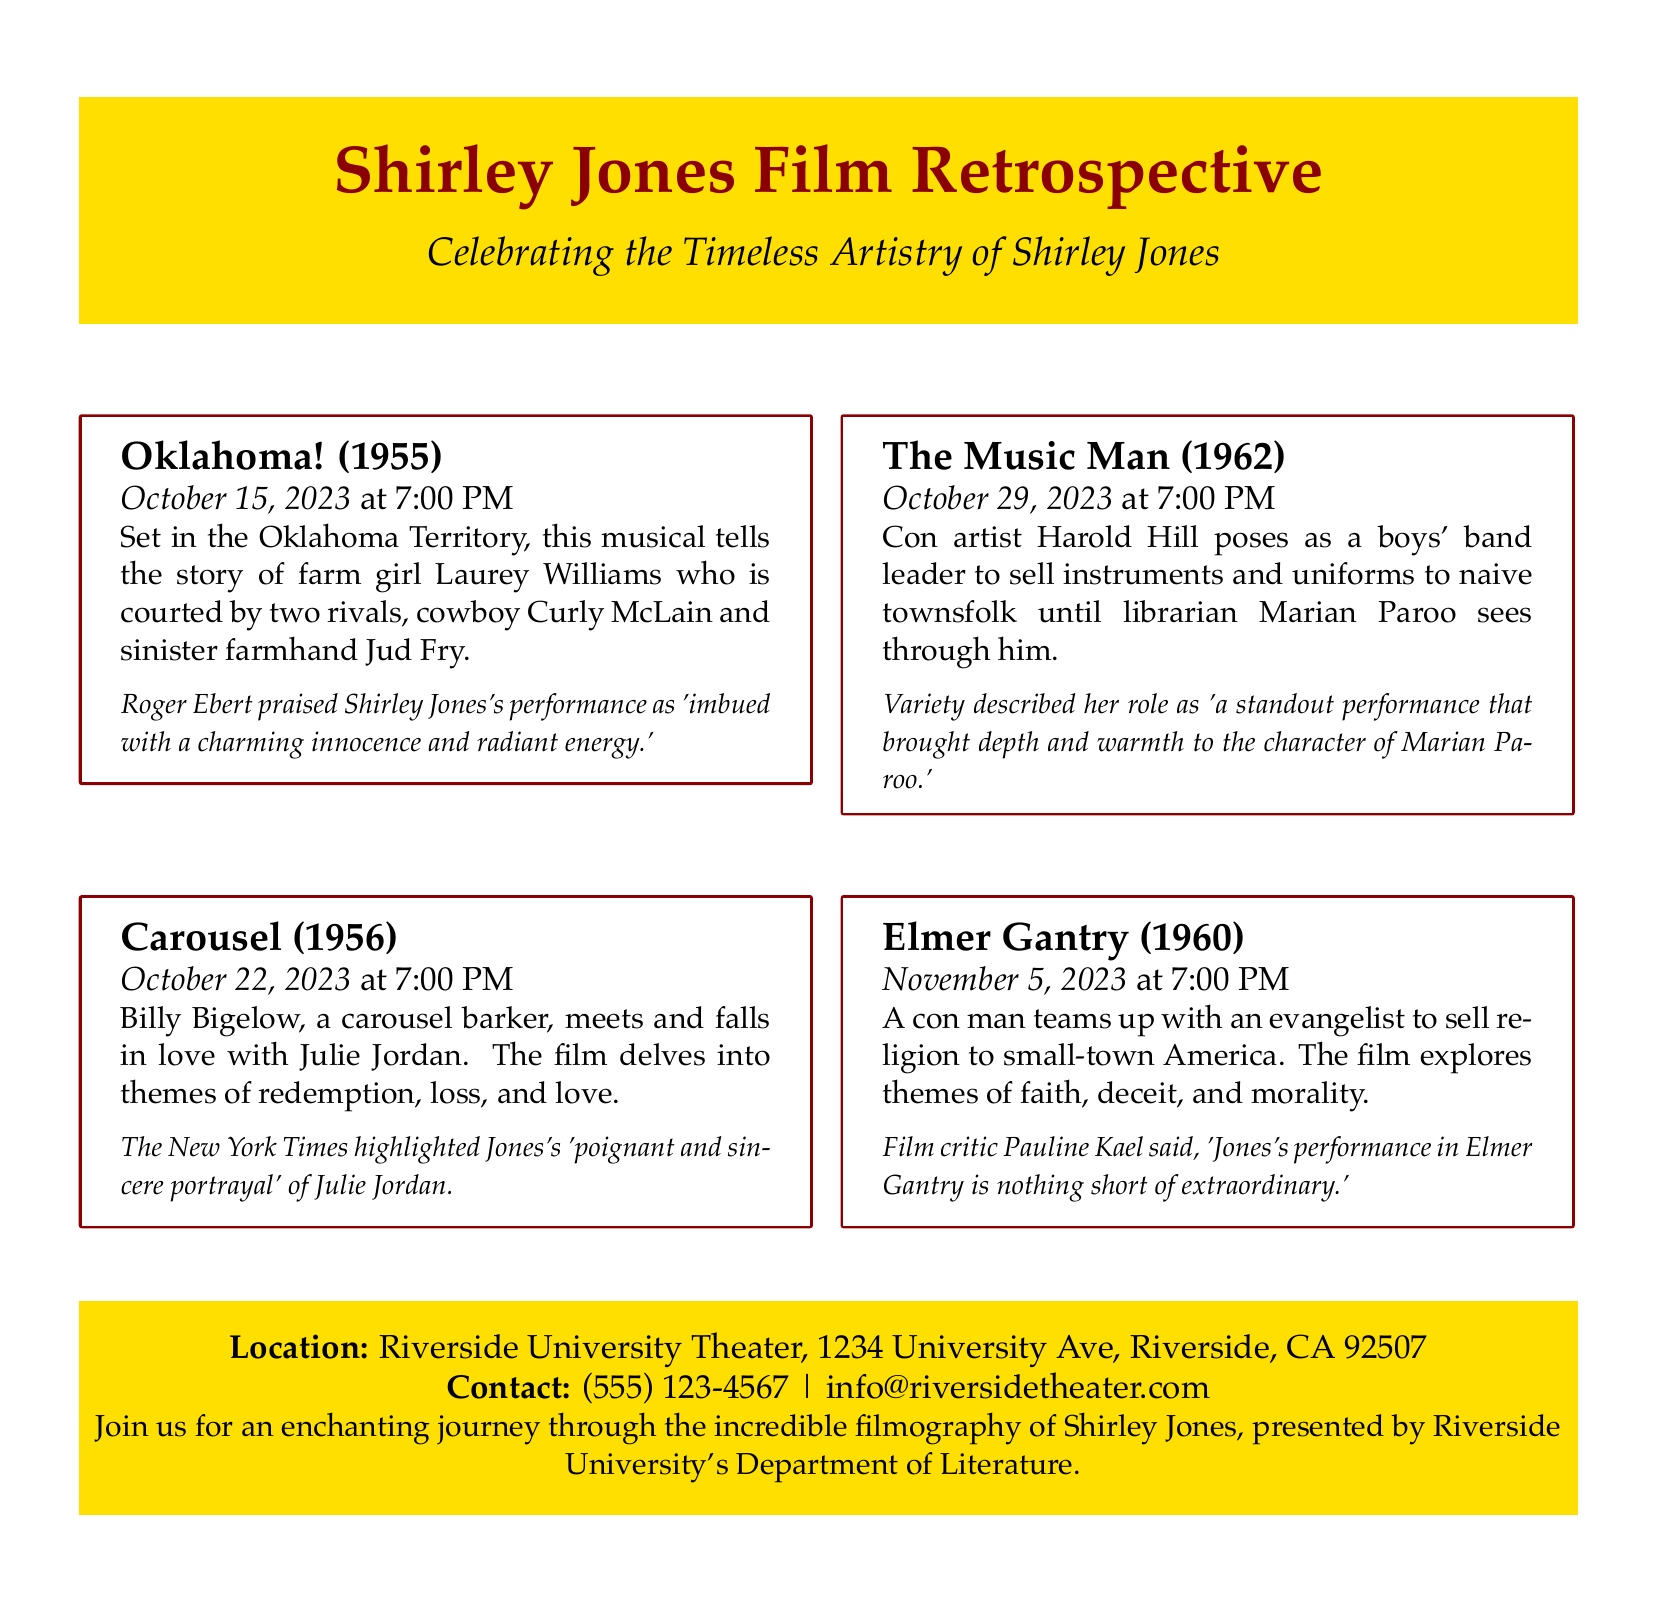What is the title of the event? The document prominently displays the title of the event at the top, which is "Shirley Jones Film Retrospective."
Answer: Shirley Jones Film Retrospective What is the location of the screenings? The flyer mentions the venue where the film screenings will take place, which is Riverside University Theater.
Answer: Riverside University Theater What date is "Oklahoma!" screening? The flyer lists the screening date for "Oklahoma!" specifically.
Answer: October 15, 2023 How many films are showcased in the retrospective? The document mentions the number of films included in the retrospective, which is four.
Answer: Four Who is the contact person for the event? The contact information is provided at the bottom of the flyer, indicating who to reach out to for inquiries.
Answer: (555) 123-4567 Which film features the character Marian Paroo? The document describes a film where Marian Paroo is a central character, which is "The Music Man."
Answer: The Music Man What type of event is being organized? The nature of the event is described, and it is focused on film screenings.
Answer: Film screenings Which movie's performance did Roger Ebert praise? The document explicitly mentions Roger Ebert’s praise for Shirley Jones's performance in "Oklahoma!"
Answer: Oklahoma! What is the purpose of this retrospective? The flyer indicates the main aim of the event is to celebrate Shirley Jones's artistry.
Answer: Celebrating the Timeless Artistry of Shirley Jones 